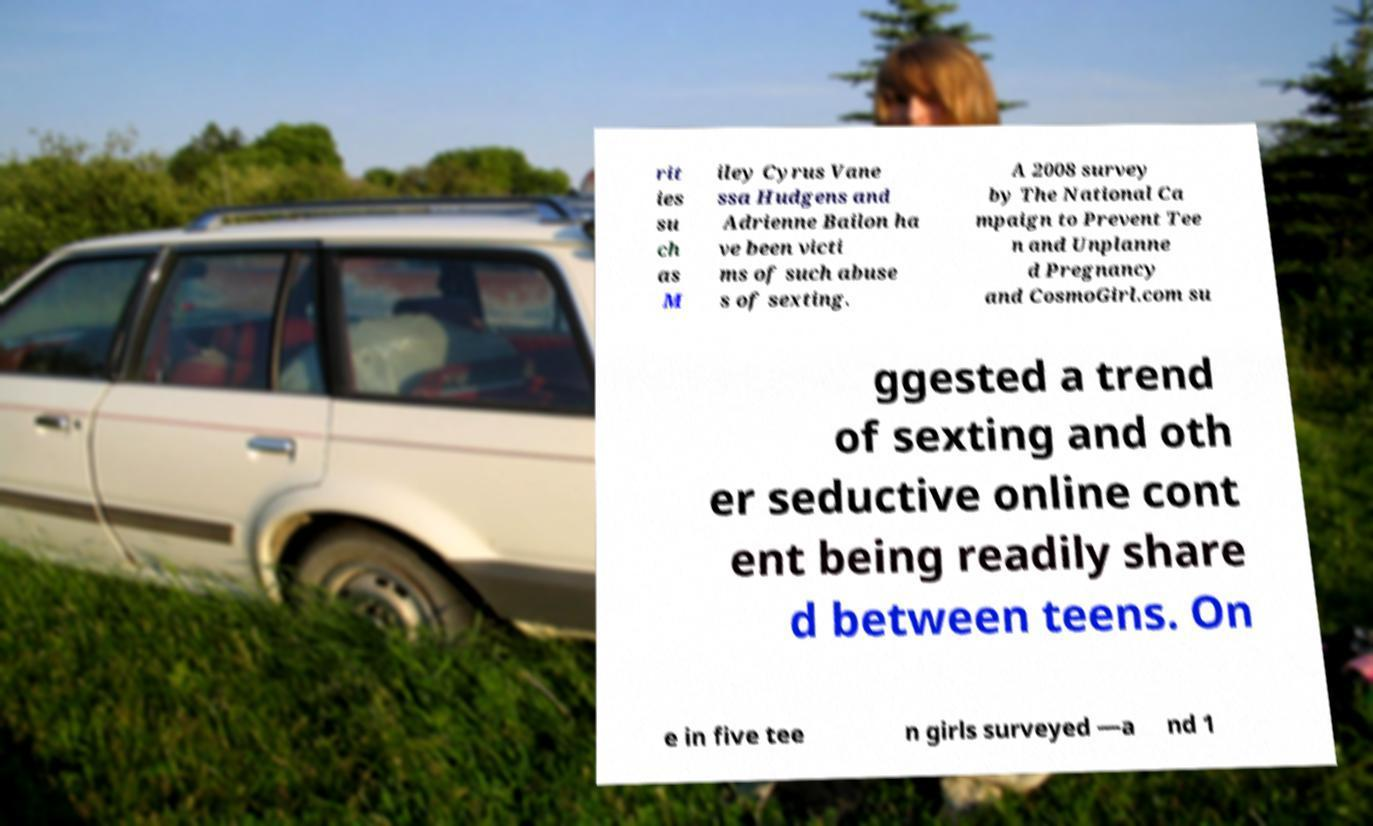Could you assist in decoding the text presented in this image and type it out clearly? rit ies su ch as M iley Cyrus Vane ssa Hudgens and Adrienne Bailon ha ve been victi ms of such abuse s of sexting. A 2008 survey by The National Ca mpaign to Prevent Tee n and Unplanne d Pregnancy and CosmoGirl.com su ggested a trend of sexting and oth er seductive online cont ent being readily share d between teens. On e in five tee n girls surveyed —a nd 1 